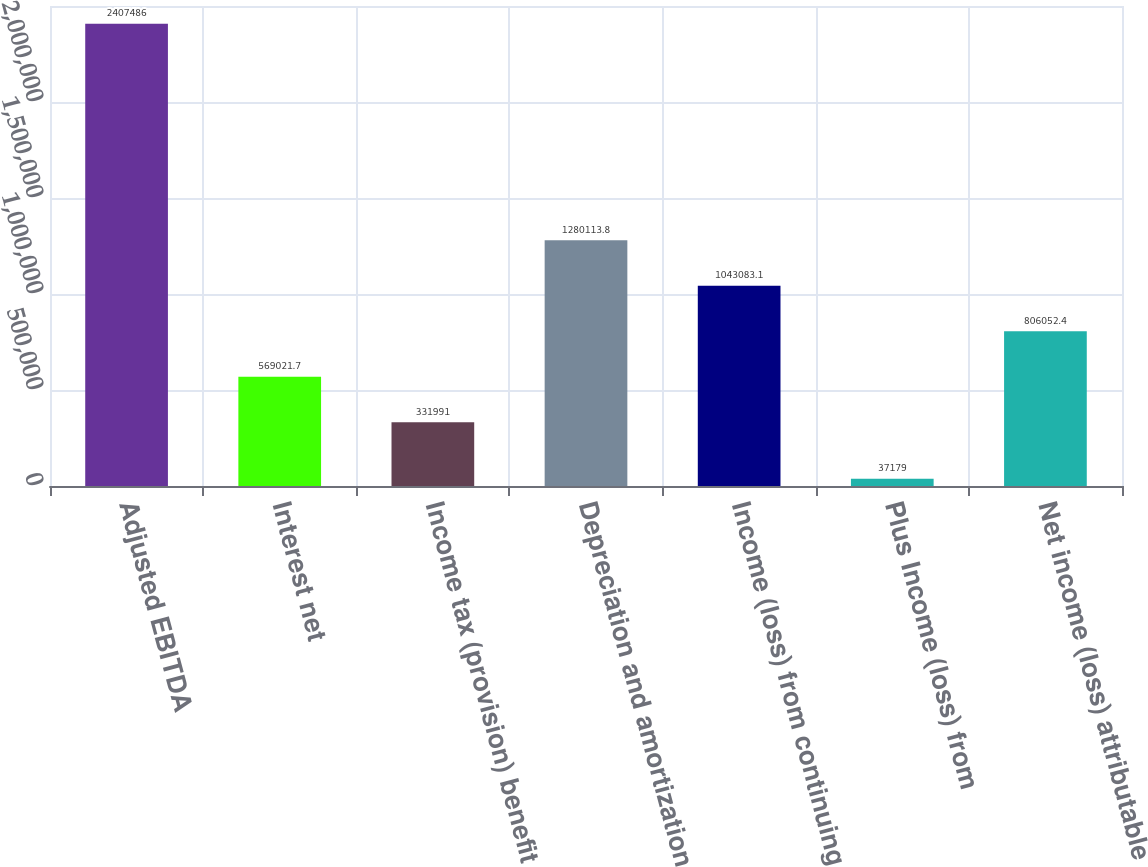Convert chart to OTSL. <chart><loc_0><loc_0><loc_500><loc_500><bar_chart><fcel>Adjusted EBITDA<fcel>Interest net<fcel>Income tax (provision) benefit<fcel>Depreciation and amortization<fcel>Income (loss) from continuing<fcel>Plus Income (loss) from<fcel>Net income (loss) attributable<nl><fcel>2.40749e+06<fcel>569022<fcel>331991<fcel>1.28011e+06<fcel>1.04308e+06<fcel>37179<fcel>806052<nl></chart> 